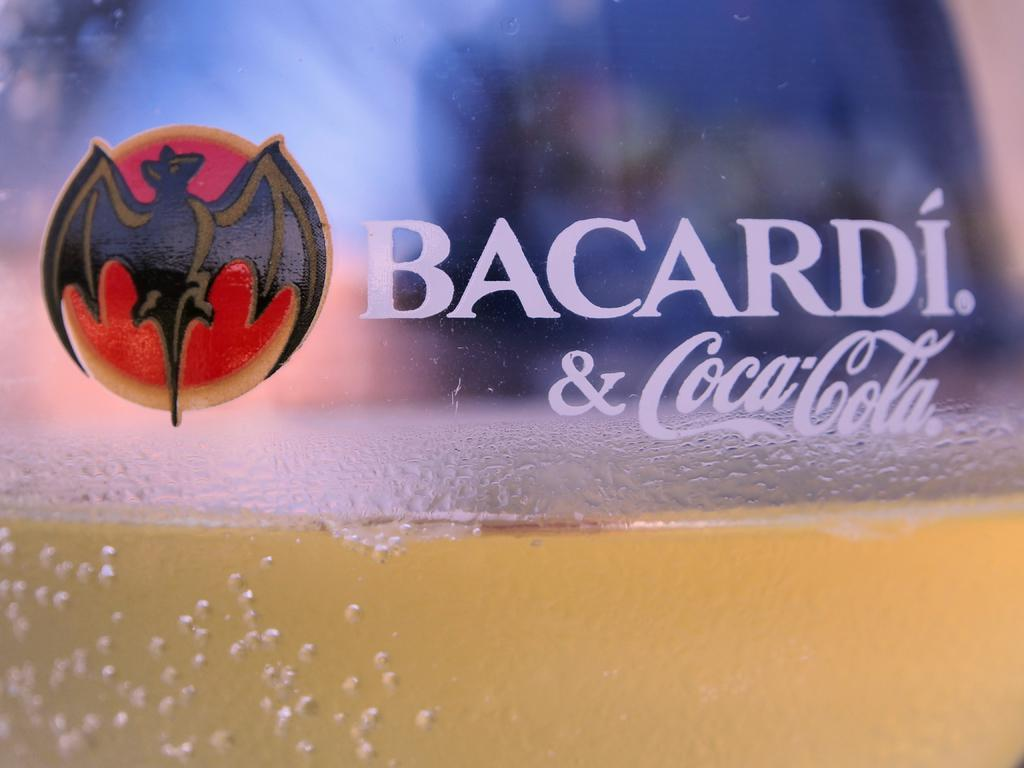<image>
Offer a succinct explanation of the picture presented. A glass half full labeled with Bacardi and Coca Cola. 